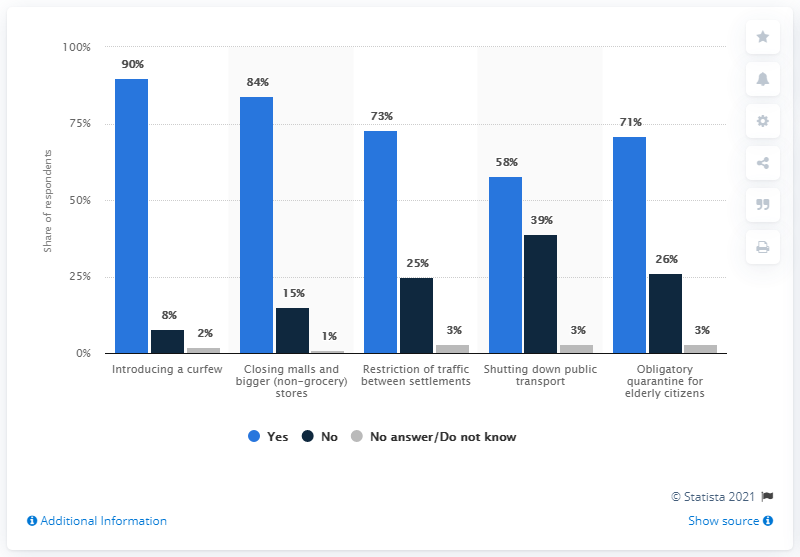Give some essential details in this illustration. The average answer to the question "Are you in favor of the restrictive measures being implemented?" was "yes," with a score of 75.2. Yes" has the most responses compared to the other options. 